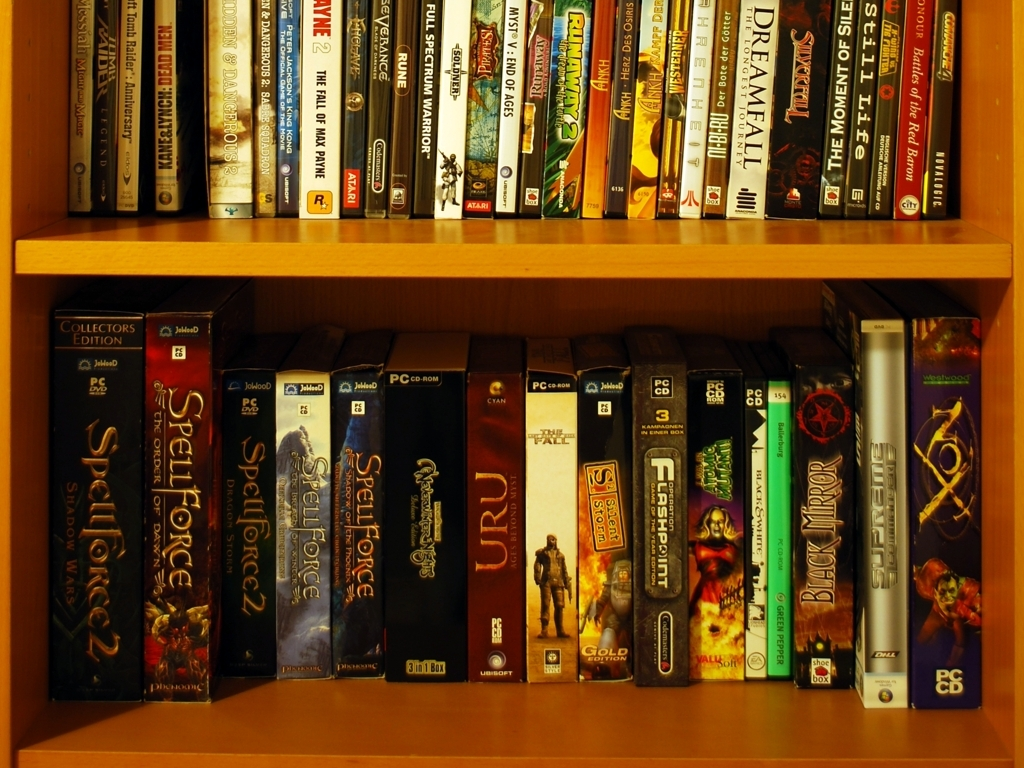Which gaming platforms are the video games in the image designed for? The games visible in the image are primarily designed for PC (Personal Computer), as indicated by the 'PC CD' or 'PC DVD' labels on their spines. PC gaming is known for its diverse library and has a long-standing community of developers and players. 